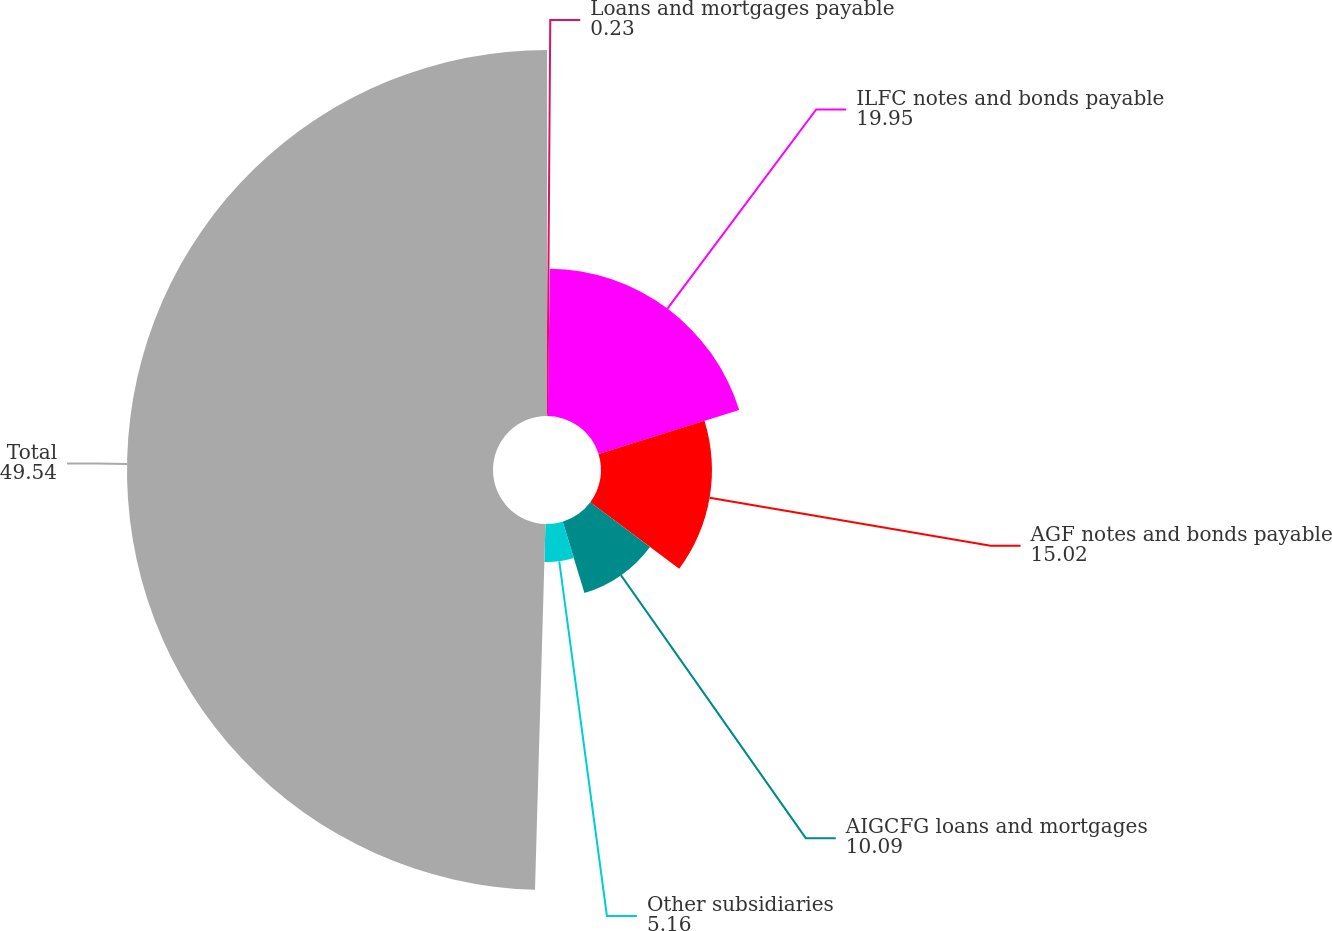Convert chart. <chart><loc_0><loc_0><loc_500><loc_500><pie_chart><fcel>Loans and mortgages payable<fcel>ILFC notes and bonds payable<fcel>AGF notes and bonds payable<fcel>AIGCFG loans and mortgages<fcel>Other subsidiaries<fcel>Total<nl><fcel>0.23%<fcel>19.95%<fcel>15.02%<fcel>10.09%<fcel>5.16%<fcel>49.54%<nl></chart> 